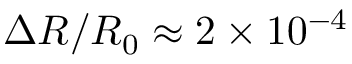Convert formula to latex. <formula><loc_0><loc_0><loc_500><loc_500>\Delta R / R _ { 0 } \approx 2 \times 1 0 ^ { - 4 }</formula> 